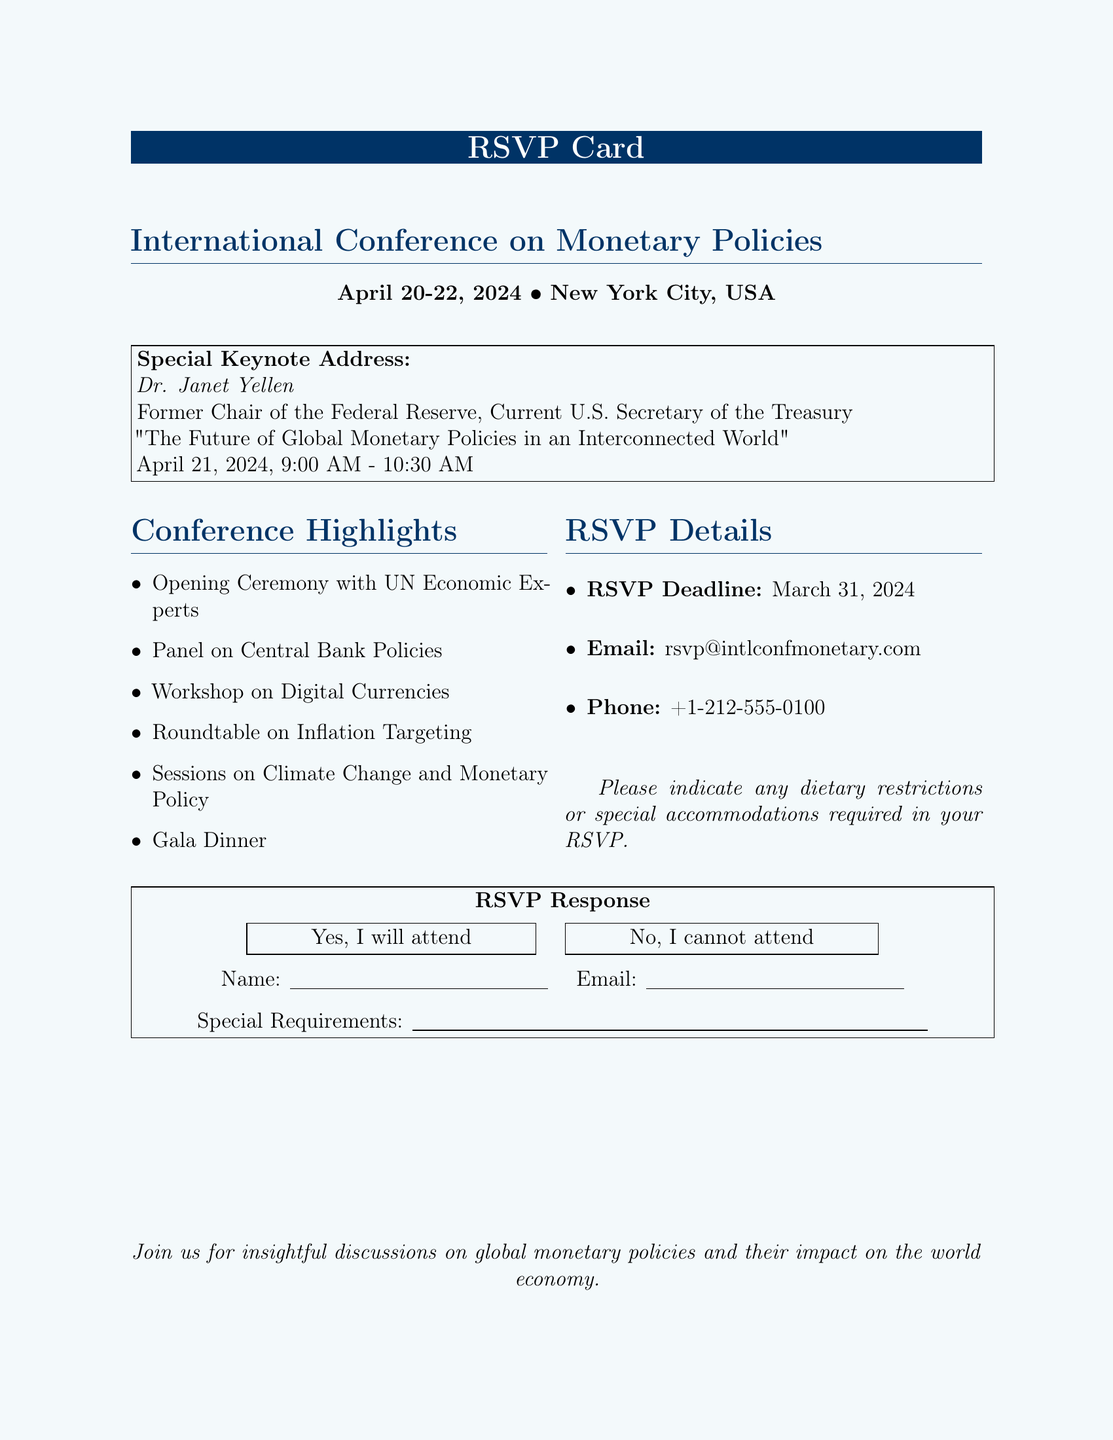What are the dates of the conference? The dates for the International Conference on Monetary Policies are mentioned clearly in the document.
Answer: April 20-22, 2024 Who is the keynote speaker? The document specifies the individual delivering the keynote address and their title.
Answer: Dr. Janet Yellen What is the title of the keynote address? The title of Dr. Janet Yellen’s keynote address is explicitly stated in the document.
Answer: The Future of Global Monetary Policies in an Interconnected World When is the keynote address scheduled? The schedule for the keynote address is given, including the date and time.
Answer: April 21, 2024, 9:00 AM - 10:30 AM What is the RSVP deadline? The deadline for RSVPs is clearly stated in the details section of the document.
Answer: March 31, 2024 What is the main topic of the panel discussion? The document lists the topics for various sessions, including the panel discussion.
Answer: Central Bank Policies What is the contact email for RSVPs? The email address for RSVP responses is provided in the document.
Answer: rsvp@intlconfmonetary.com What event follows the opening ceremony? The highlights section lists the order of events for clarity.
Answer: Panel on Central Bank Policies What should attendees indicate in their RSVP? Special requirements for attendees are mentioned in the RSVP details.
Answer: Dietary restrictions or special accommodations 